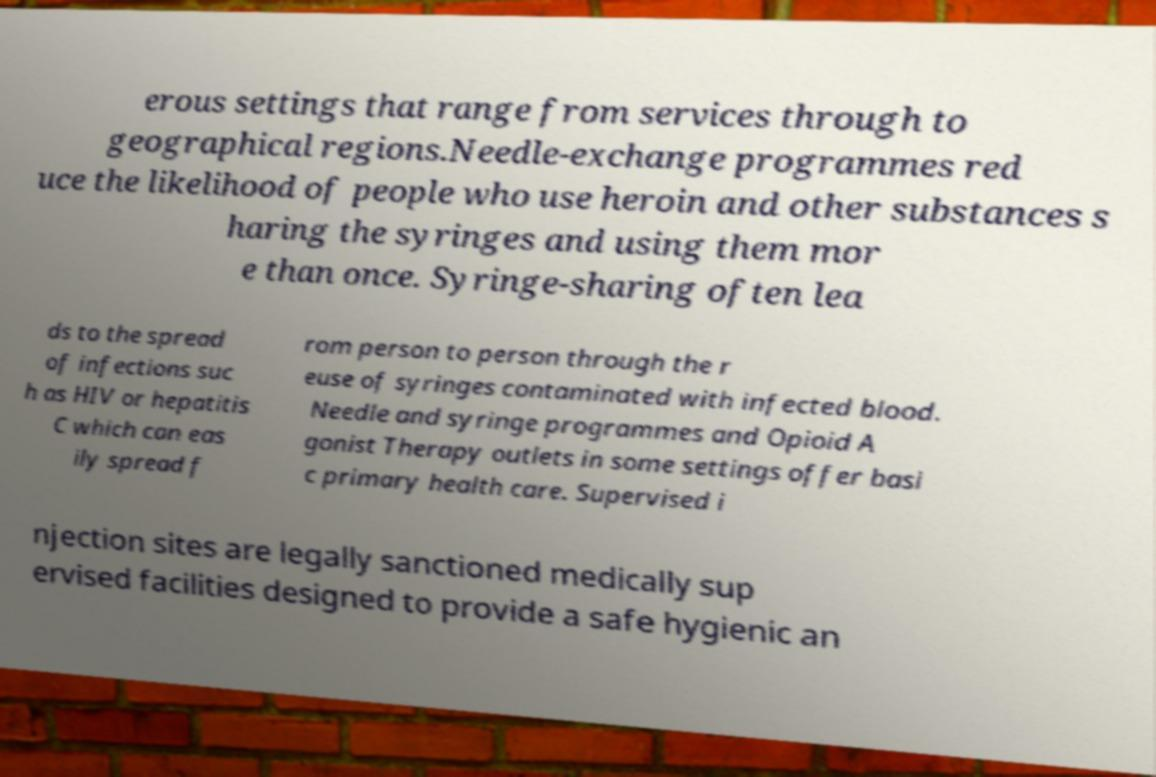Can you read and provide the text displayed in the image?This photo seems to have some interesting text. Can you extract and type it out for me? erous settings that range from services through to geographical regions.Needle-exchange programmes red uce the likelihood of people who use heroin and other substances s haring the syringes and using them mor e than once. Syringe-sharing often lea ds to the spread of infections suc h as HIV or hepatitis C which can eas ily spread f rom person to person through the r euse of syringes contaminated with infected blood. Needle and syringe programmes and Opioid A gonist Therapy outlets in some settings offer basi c primary health care. Supervised i njection sites are legally sanctioned medically sup ervised facilities designed to provide a safe hygienic an 